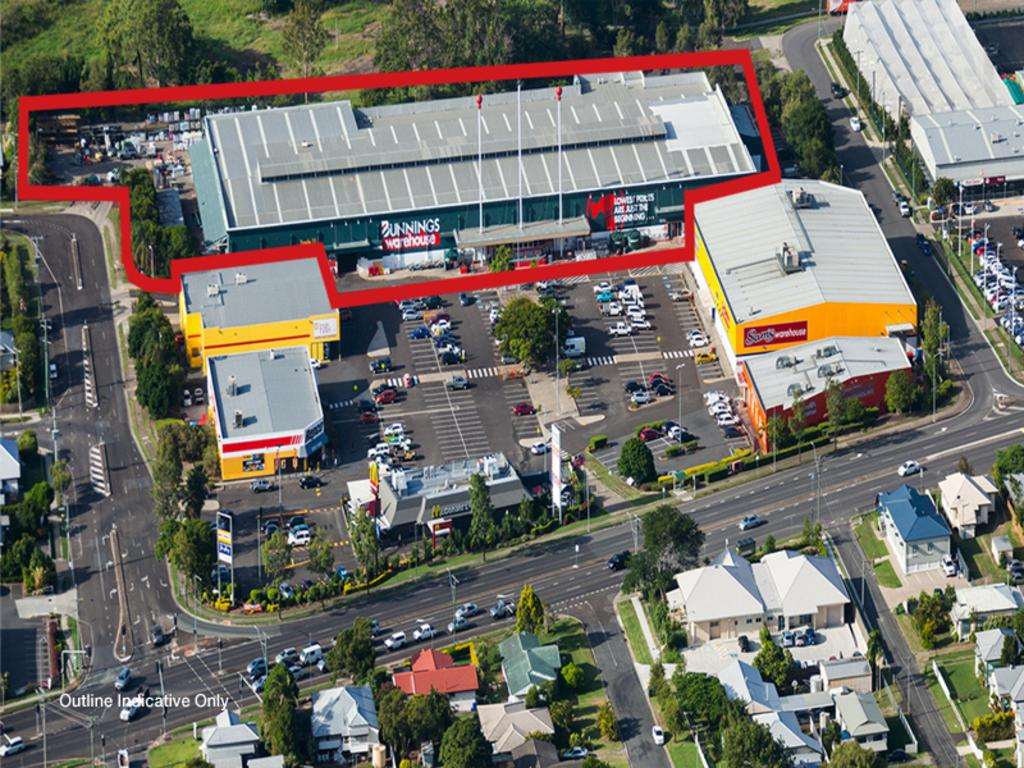What can be seen on the road in the image? There are cars on the road in the image. What type of structures are visible in the image? There are buildings in the image. What natural elements can be seen in the image? There are trees in the image. What type of advertising is present in the image? There are hoardings in the image. What type of lighting is present in the image? There are street lights in the image. What type of vertical structures are present in the image? There are poles in the image. What can be seen on the left side of the image? There is some text on the left side of the image. Is there an amusement park visible in the image? No, there is no amusement park visible in the image. What is the slope of the road in the image? The text does not mention the slope of the road, and it cannot be determined from the image. 